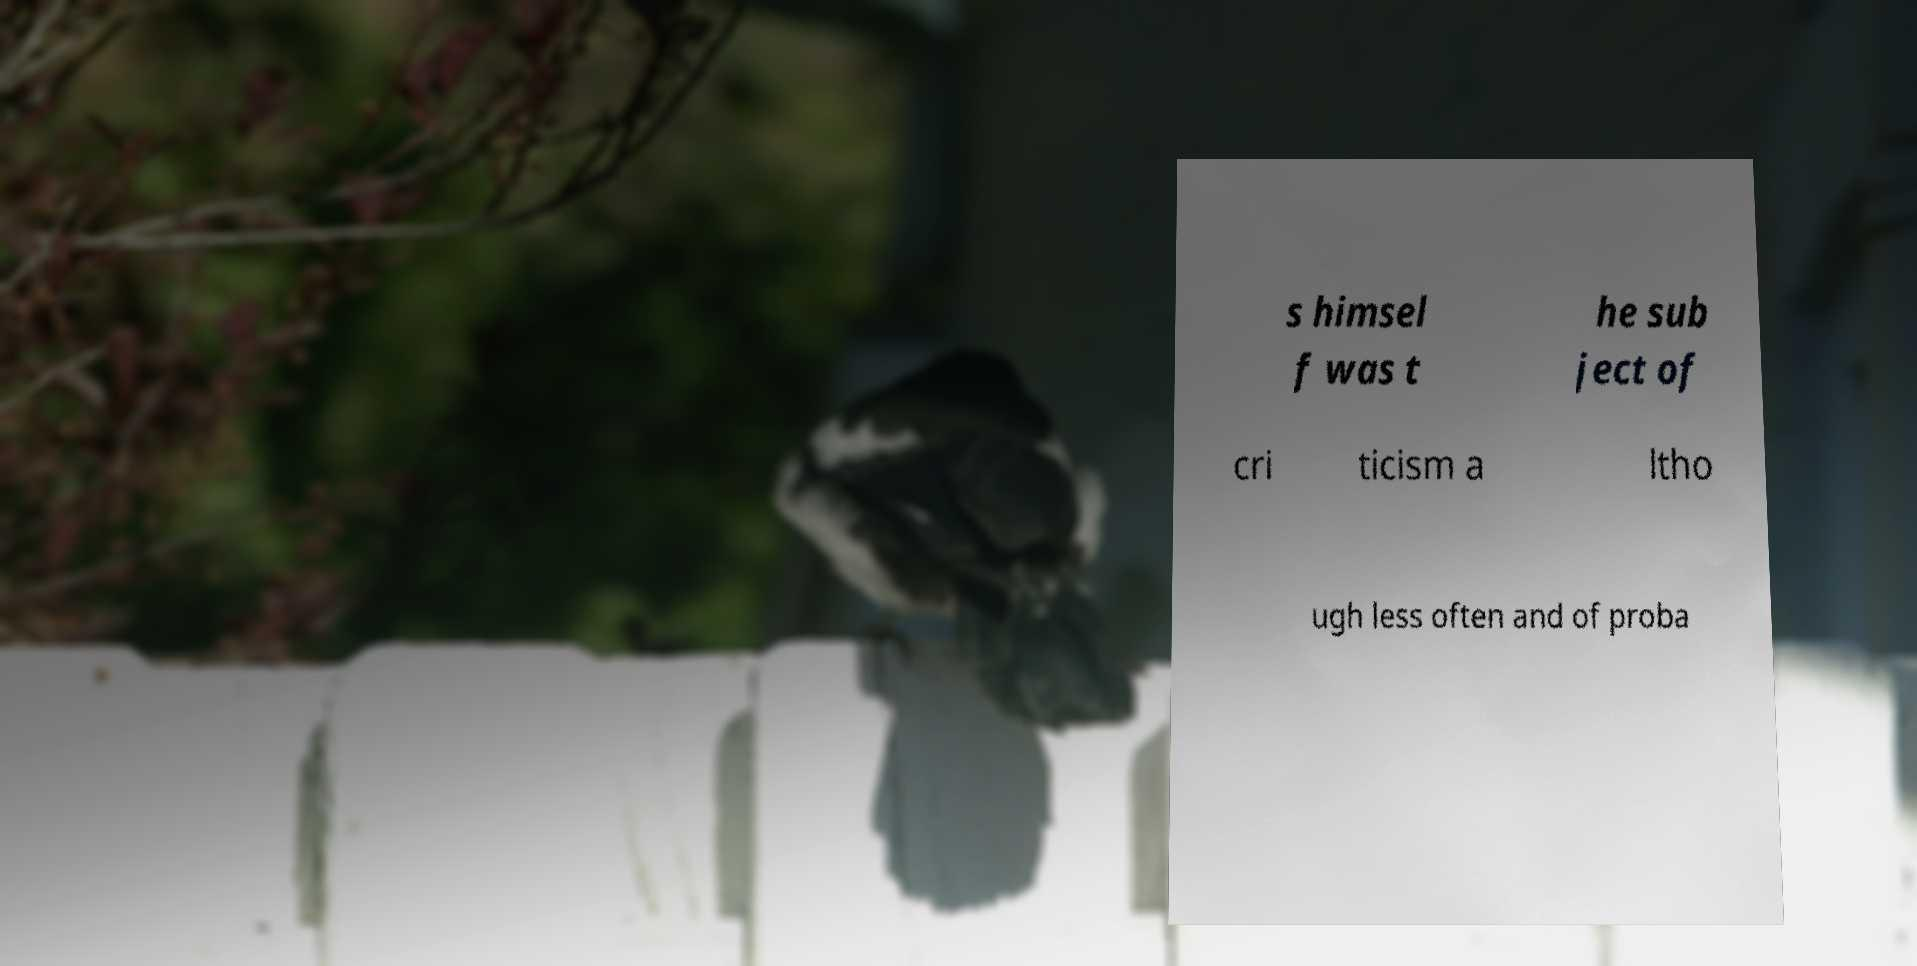Please identify and transcribe the text found in this image. s himsel f was t he sub ject of cri ticism a ltho ugh less often and of proba 